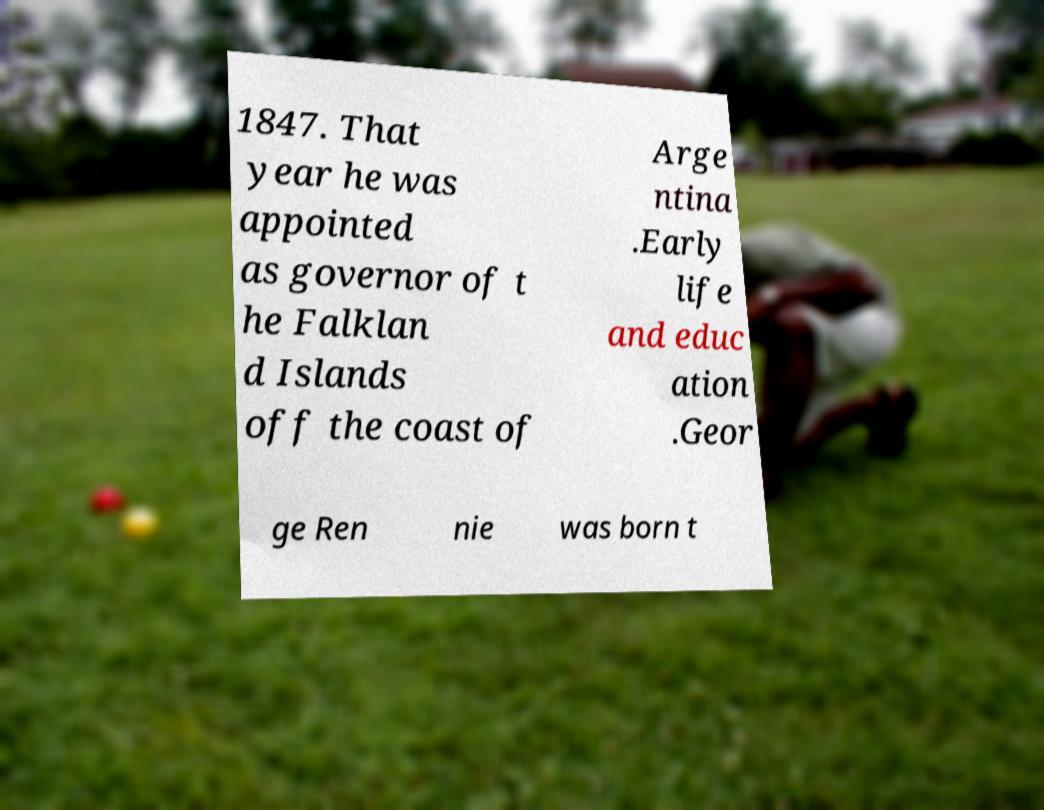What messages or text are displayed in this image? I need them in a readable, typed format. 1847. That year he was appointed as governor of t he Falklan d Islands off the coast of Arge ntina .Early life and educ ation .Geor ge Ren nie was born t 